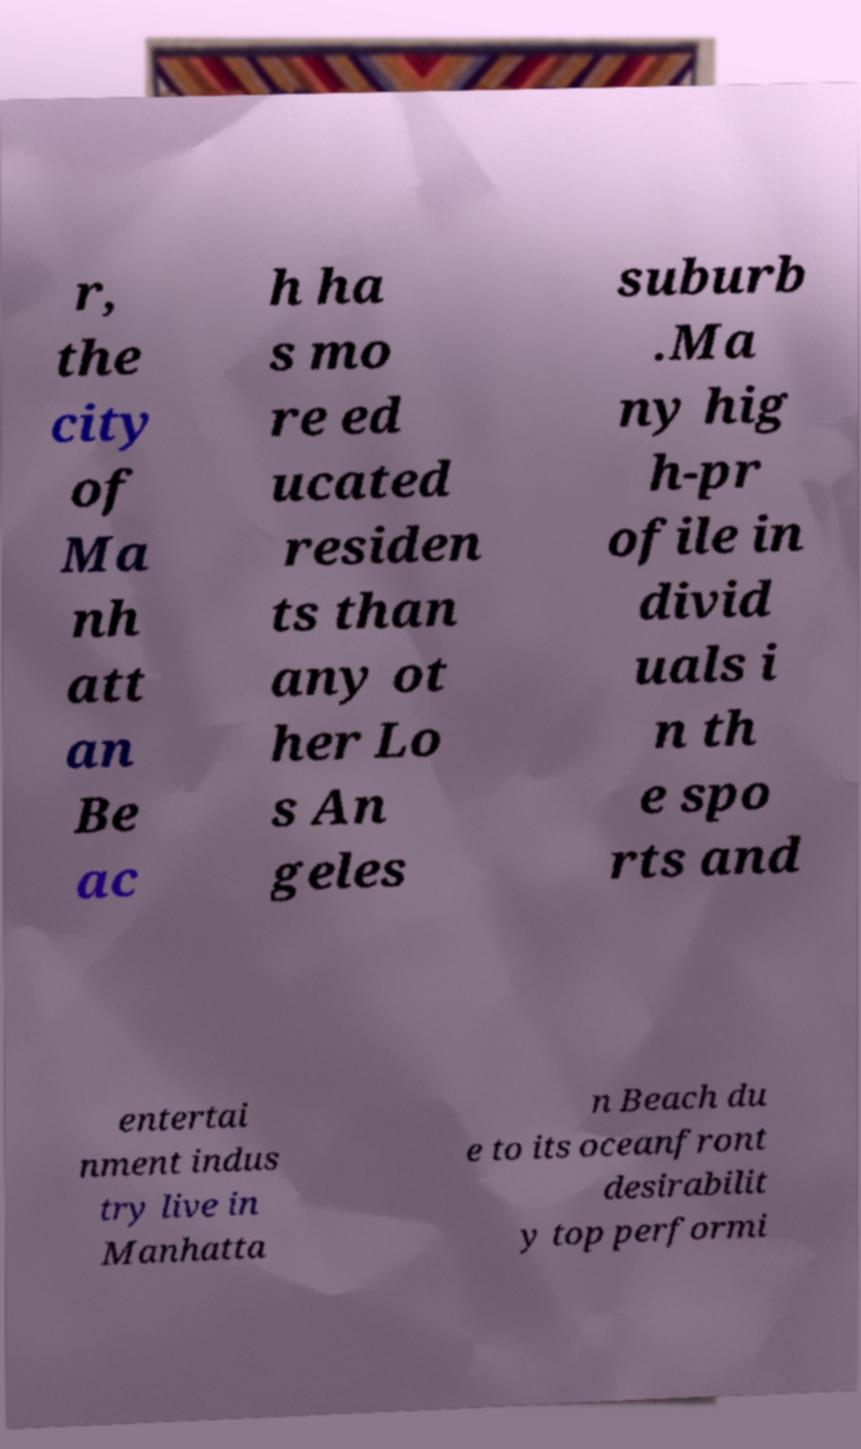Could you extract and type out the text from this image? r, the city of Ma nh att an Be ac h ha s mo re ed ucated residen ts than any ot her Lo s An geles suburb .Ma ny hig h-pr ofile in divid uals i n th e spo rts and entertai nment indus try live in Manhatta n Beach du e to its oceanfront desirabilit y top performi 